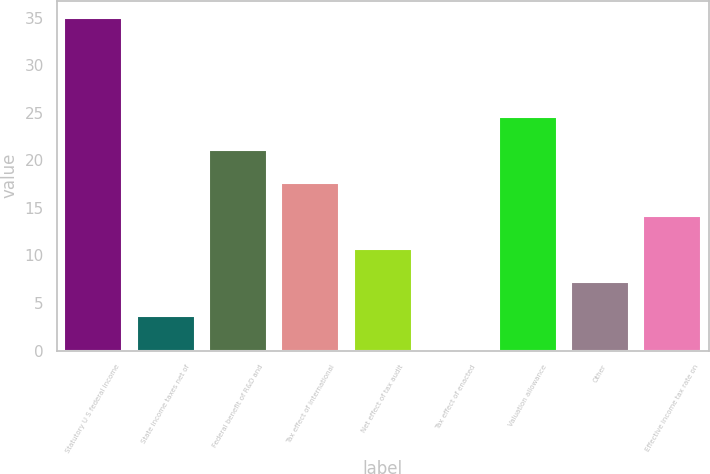Convert chart. <chart><loc_0><loc_0><loc_500><loc_500><bar_chart><fcel>Statutory U S federal income<fcel>State income taxes net of<fcel>Federal benefit of R&D and<fcel>Tax effect of international<fcel>Net effect of tax audit<fcel>Tax effect of enacted<fcel>Valuation allowance<fcel>Other<fcel>Effective income tax rate on<nl><fcel>35<fcel>3.68<fcel>21.08<fcel>17.6<fcel>10.64<fcel>0.2<fcel>24.56<fcel>7.16<fcel>14.12<nl></chart> 